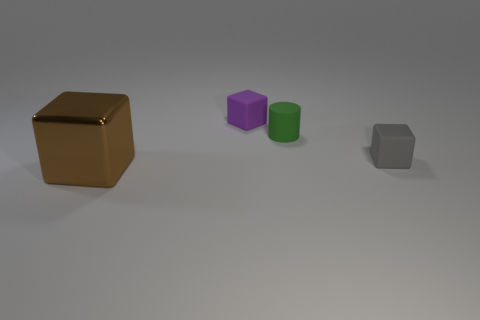Is there any other thing that has the same material as the brown cube?
Your response must be concise. No. What number of rubber objects are tiny purple cubes or large cyan balls?
Ensure brevity in your answer.  1. Do the purple matte block and the brown thing have the same size?
Offer a very short reply. No. Are there fewer metallic objects behind the purple thing than blocks that are on the left side of the gray block?
Your answer should be very brief. Yes. Is there any other thing that has the same size as the brown shiny thing?
Ensure brevity in your answer.  No. The brown object is what size?
Offer a very short reply. Large. What number of tiny objects are cyan spheres or purple blocks?
Provide a succinct answer. 1. There is a rubber cylinder; does it have the same size as the block left of the small purple object?
Offer a very short reply. No. Are there any other things that are the same shape as the green object?
Offer a very short reply. No. What number of green rubber cylinders are there?
Give a very brief answer. 1. 